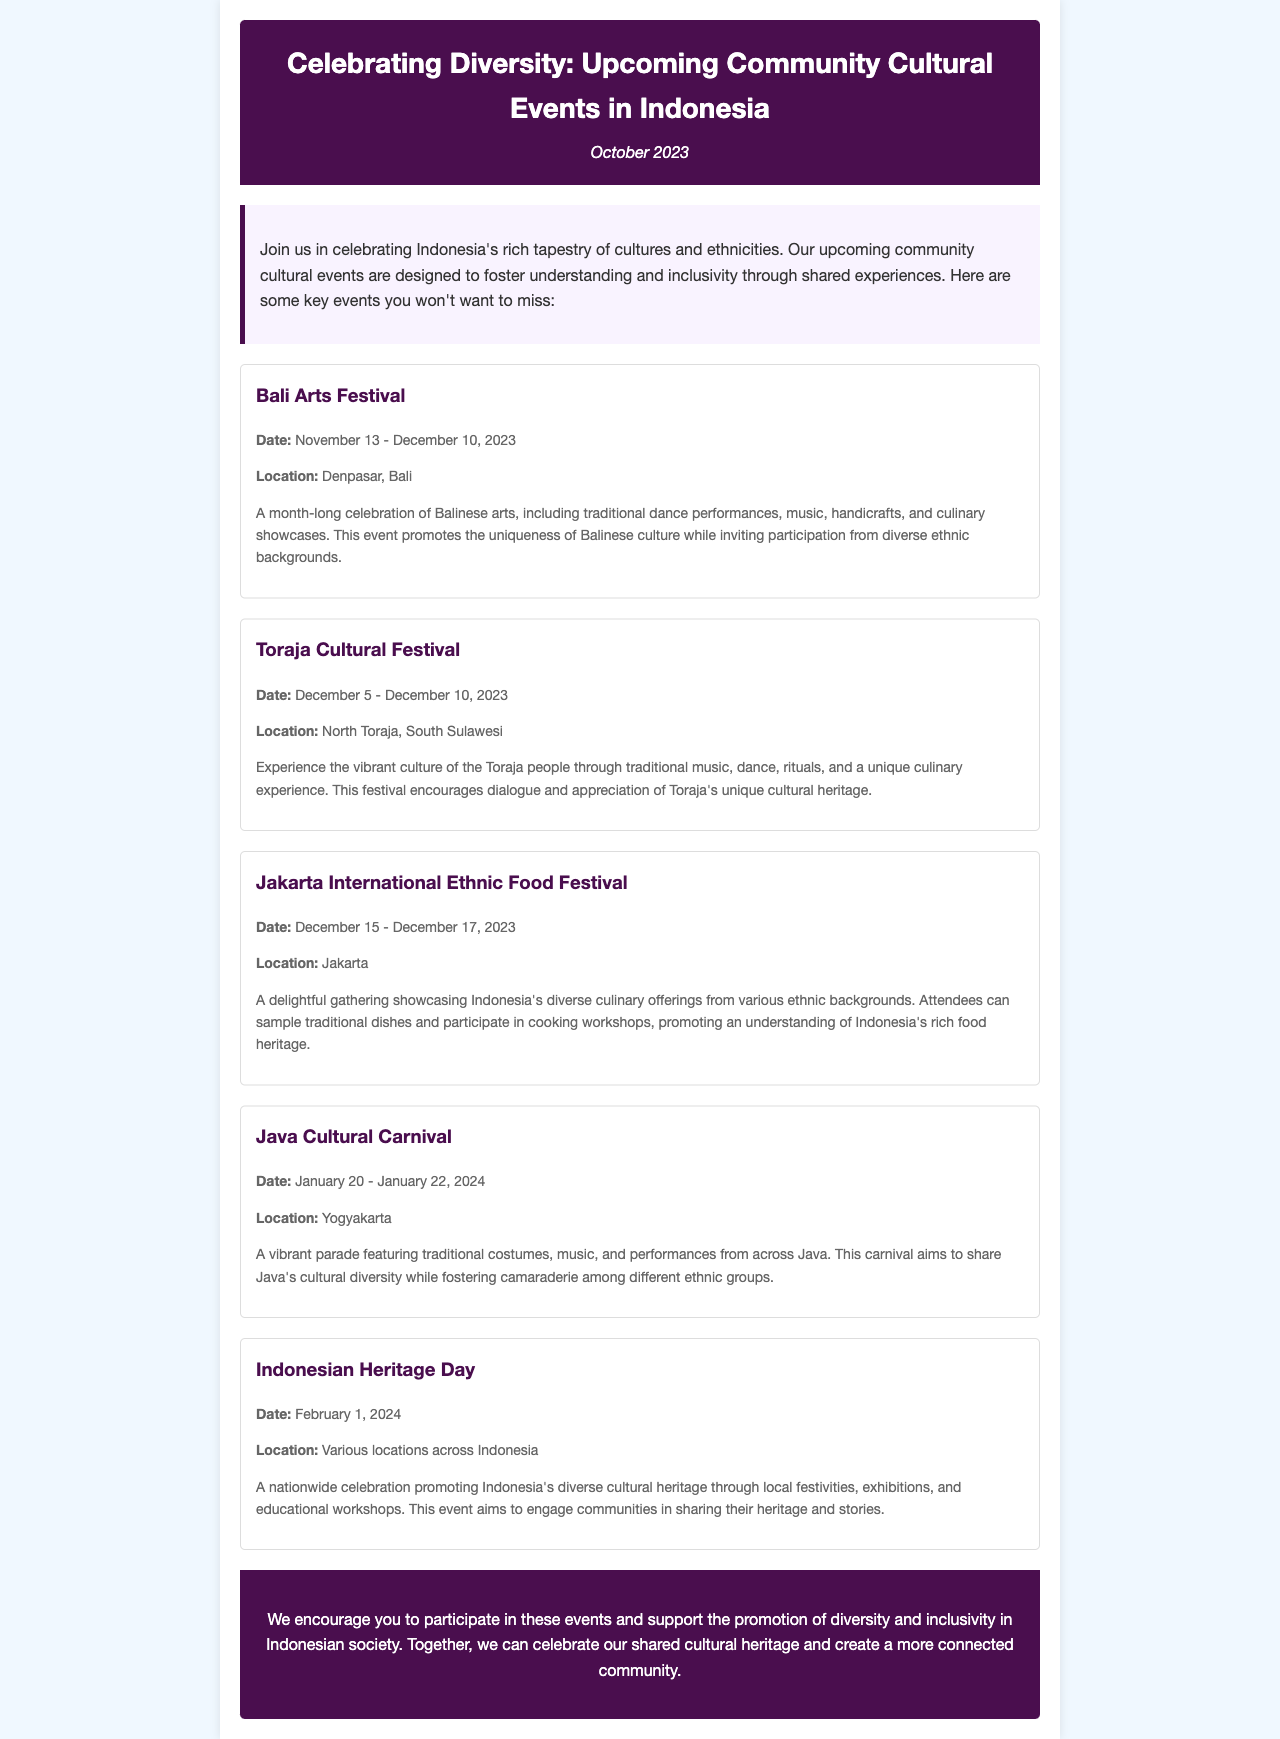What is the title of the newsletter? The title of the newsletter is displayed prominently at the top of the document in the header section.
Answer: Celebrating Diversity: Upcoming Community Cultural Events in Indonesia When does the Bali Arts Festival take place? The date of the Bali Arts Festival is mentioned in the event's details section.
Answer: November 13 - December 10, 2023 Where is the Jakarta International Ethnic Food Festival held? The location of the Jakarta International Ethnic Food Festival is specific to the event details provided.
Answer: Jakarta What cultural aspects does the Toraja Cultural Festival emphasize? The description of the Toraja Cultural Festival highlights specific cultural elements.
Answer: Traditional music, dance, rituals, and culinary experience What is the purpose of Indonesian Heritage Day? The document explains the aim of Indonesian Heritage Day in a concise manner within its event details.
Answer: Promoting Indonesia's diverse cultural heritage How many days does the Java Cultural Carnival last? The duration of the Java Cultural Carnival is mentioned in the event details.
Answer: 3 days Which event encourages participation from diverse ethnic backgrounds? The events are specifically designed to invite participation and promote inclusivity, highlighted in event descriptions.
Answer: Bali Arts Festival What type of event is scheduled for February 1, 2024? The document provides information about the nature of the event on this date in its summary.
Answer: Indonesian Heritage Day 